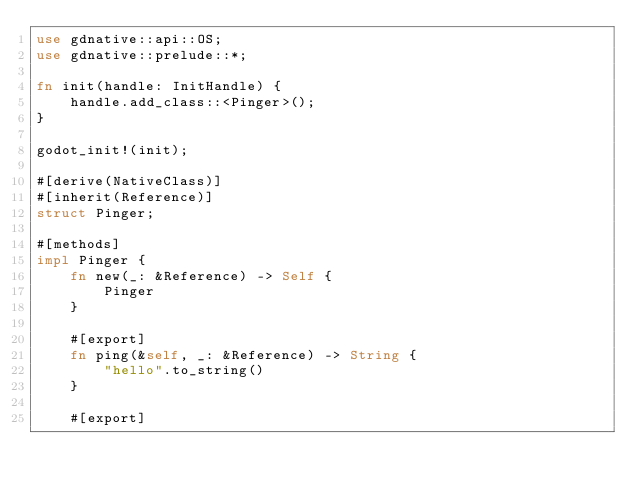<code> <loc_0><loc_0><loc_500><loc_500><_Rust_>use gdnative::api::OS;
use gdnative::prelude::*;

fn init(handle: InitHandle) {
    handle.add_class::<Pinger>();
}

godot_init!(init);

#[derive(NativeClass)]
#[inherit(Reference)]
struct Pinger;

#[methods]
impl Pinger {
    fn new(_: &Reference) -> Self {
        Pinger
    }

    #[export]
    fn ping(&self, _: &Reference) -> String {
        "hello".to_string()
    }

    #[export]</code> 